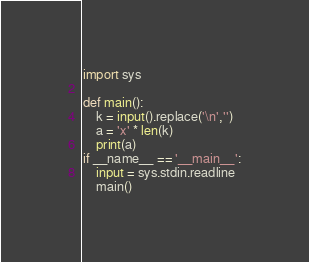Convert code to text. <code><loc_0><loc_0><loc_500><loc_500><_Python_>import sys

def main():
    k = input().replace('\n','')
    a = 'x' * len(k)
    print(a)
if __name__ == '__main__':
    input = sys.stdin.readline
    main()
</code> 